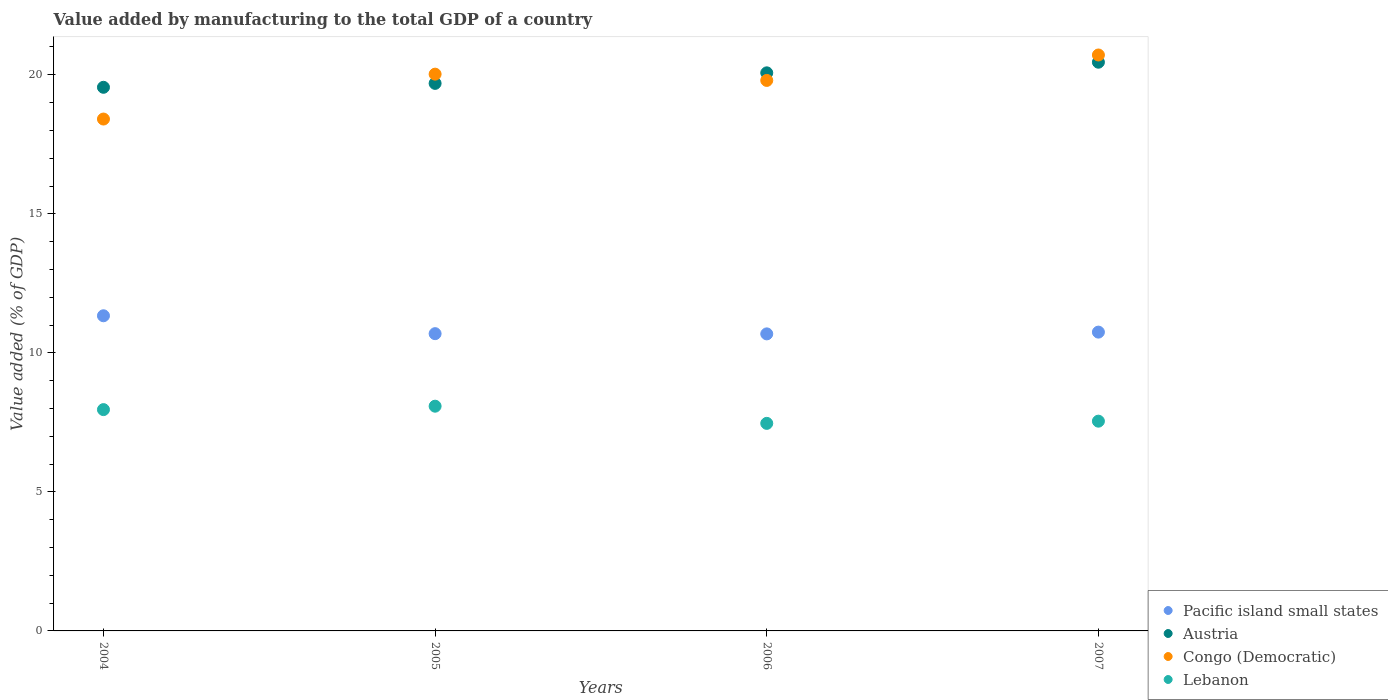How many different coloured dotlines are there?
Your answer should be very brief. 4. What is the value added by manufacturing to the total GDP in Austria in 2007?
Your response must be concise. 20.45. Across all years, what is the maximum value added by manufacturing to the total GDP in Pacific island small states?
Make the answer very short. 11.33. Across all years, what is the minimum value added by manufacturing to the total GDP in Pacific island small states?
Offer a terse response. 10.68. In which year was the value added by manufacturing to the total GDP in Pacific island small states minimum?
Make the answer very short. 2006. What is the total value added by manufacturing to the total GDP in Congo (Democratic) in the graph?
Ensure brevity in your answer.  78.94. What is the difference between the value added by manufacturing to the total GDP in Austria in 2006 and that in 2007?
Offer a very short reply. -0.38. What is the difference between the value added by manufacturing to the total GDP in Austria in 2004 and the value added by manufacturing to the total GDP in Pacific island small states in 2005?
Your answer should be compact. 8.86. What is the average value added by manufacturing to the total GDP in Lebanon per year?
Provide a short and direct response. 7.76. In the year 2006, what is the difference between the value added by manufacturing to the total GDP in Austria and value added by manufacturing to the total GDP in Pacific island small states?
Your response must be concise. 9.39. In how many years, is the value added by manufacturing to the total GDP in Lebanon greater than 1 %?
Your response must be concise. 4. What is the ratio of the value added by manufacturing to the total GDP in Pacific island small states in 2004 to that in 2005?
Keep it short and to the point. 1.06. What is the difference between the highest and the second highest value added by manufacturing to the total GDP in Lebanon?
Ensure brevity in your answer.  0.12. What is the difference between the highest and the lowest value added by manufacturing to the total GDP in Pacific island small states?
Your answer should be very brief. 0.65. Is the sum of the value added by manufacturing to the total GDP in Pacific island small states in 2004 and 2006 greater than the maximum value added by manufacturing to the total GDP in Austria across all years?
Your answer should be compact. Yes. Is it the case that in every year, the sum of the value added by manufacturing to the total GDP in Congo (Democratic) and value added by manufacturing to the total GDP in Pacific island small states  is greater than the sum of value added by manufacturing to the total GDP in Austria and value added by manufacturing to the total GDP in Lebanon?
Make the answer very short. Yes. Is it the case that in every year, the sum of the value added by manufacturing to the total GDP in Pacific island small states and value added by manufacturing to the total GDP in Austria  is greater than the value added by manufacturing to the total GDP in Congo (Democratic)?
Offer a very short reply. Yes. Is the value added by manufacturing to the total GDP in Austria strictly greater than the value added by manufacturing to the total GDP in Congo (Democratic) over the years?
Offer a terse response. No. Is the value added by manufacturing to the total GDP in Austria strictly less than the value added by manufacturing to the total GDP in Lebanon over the years?
Offer a terse response. No. Are the values on the major ticks of Y-axis written in scientific E-notation?
Offer a very short reply. No. Does the graph contain grids?
Offer a terse response. No. What is the title of the graph?
Give a very brief answer. Value added by manufacturing to the total GDP of a country. What is the label or title of the Y-axis?
Provide a succinct answer. Value added (% of GDP). What is the Value added (% of GDP) in Pacific island small states in 2004?
Offer a very short reply. 11.33. What is the Value added (% of GDP) in Austria in 2004?
Give a very brief answer. 19.55. What is the Value added (% of GDP) of Congo (Democratic) in 2004?
Offer a very short reply. 18.41. What is the Value added (% of GDP) of Lebanon in 2004?
Provide a short and direct response. 7.96. What is the Value added (% of GDP) in Pacific island small states in 2005?
Give a very brief answer. 10.69. What is the Value added (% of GDP) of Austria in 2005?
Your answer should be very brief. 19.69. What is the Value added (% of GDP) of Congo (Democratic) in 2005?
Give a very brief answer. 20.02. What is the Value added (% of GDP) of Lebanon in 2005?
Offer a terse response. 8.08. What is the Value added (% of GDP) in Pacific island small states in 2006?
Your response must be concise. 10.68. What is the Value added (% of GDP) in Austria in 2006?
Keep it short and to the point. 20.07. What is the Value added (% of GDP) of Congo (Democratic) in 2006?
Give a very brief answer. 19.8. What is the Value added (% of GDP) of Lebanon in 2006?
Provide a succinct answer. 7.46. What is the Value added (% of GDP) of Pacific island small states in 2007?
Your answer should be compact. 10.75. What is the Value added (% of GDP) in Austria in 2007?
Give a very brief answer. 20.45. What is the Value added (% of GDP) of Congo (Democratic) in 2007?
Your response must be concise. 20.71. What is the Value added (% of GDP) of Lebanon in 2007?
Your answer should be very brief. 7.54. Across all years, what is the maximum Value added (% of GDP) of Pacific island small states?
Make the answer very short. 11.33. Across all years, what is the maximum Value added (% of GDP) in Austria?
Your response must be concise. 20.45. Across all years, what is the maximum Value added (% of GDP) of Congo (Democratic)?
Provide a short and direct response. 20.71. Across all years, what is the maximum Value added (% of GDP) in Lebanon?
Offer a very short reply. 8.08. Across all years, what is the minimum Value added (% of GDP) in Pacific island small states?
Your answer should be compact. 10.68. Across all years, what is the minimum Value added (% of GDP) of Austria?
Offer a terse response. 19.55. Across all years, what is the minimum Value added (% of GDP) in Congo (Democratic)?
Your answer should be compact. 18.41. Across all years, what is the minimum Value added (% of GDP) in Lebanon?
Provide a succinct answer. 7.46. What is the total Value added (% of GDP) of Pacific island small states in the graph?
Provide a short and direct response. 43.45. What is the total Value added (% of GDP) in Austria in the graph?
Your response must be concise. 79.76. What is the total Value added (% of GDP) in Congo (Democratic) in the graph?
Your answer should be very brief. 78.94. What is the total Value added (% of GDP) in Lebanon in the graph?
Give a very brief answer. 31.05. What is the difference between the Value added (% of GDP) in Pacific island small states in 2004 and that in 2005?
Ensure brevity in your answer.  0.64. What is the difference between the Value added (% of GDP) of Austria in 2004 and that in 2005?
Offer a terse response. -0.14. What is the difference between the Value added (% of GDP) of Congo (Democratic) in 2004 and that in 2005?
Offer a terse response. -1.61. What is the difference between the Value added (% of GDP) of Lebanon in 2004 and that in 2005?
Provide a succinct answer. -0.12. What is the difference between the Value added (% of GDP) in Pacific island small states in 2004 and that in 2006?
Your answer should be compact. 0.65. What is the difference between the Value added (% of GDP) of Austria in 2004 and that in 2006?
Provide a succinct answer. -0.52. What is the difference between the Value added (% of GDP) in Congo (Democratic) in 2004 and that in 2006?
Your answer should be compact. -1.39. What is the difference between the Value added (% of GDP) in Lebanon in 2004 and that in 2006?
Provide a succinct answer. 0.49. What is the difference between the Value added (% of GDP) in Pacific island small states in 2004 and that in 2007?
Ensure brevity in your answer.  0.59. What is the difference between the Value added (% of GDP) in Austria in 2004 and that in 2007?
Provide a short and direct response. -0.9. What is the difference between the Value added (% of GDP) in Congo (Democratic) in 2004 and that in 2007?
Offer a very short reply. -2.3. What is the difference between the Value added (% of GDP) in Lebanon in 2004 and that in 2007?
Make the answer very short. 0.42. What is the difference between the Value added (% of GDP) of Pacific island small states in 2005 and that in 2006?
Provide a short and direct response. 0.01. What is the difference between the Value added (% of GDP) in Austria in 2005 and that in 2006?
Provide a short and direct response. -0.38. What is the difference between the Value added (% of GDP) of Congo (Democratic) in 2005 and that in 2006?
Provide a short and direct response. 0.23. What is the difference between the Value added (% of GDP) of Lebanon in 2005 and that in 2006?
Offer a terse response. 0.62. What is the difference between the Value added (% of GDP) in Pacific island small states in 2005 and that in 2007?
Offer a terse response. -0.06. What is the difference between the Value added (% of GDP) of Austria in 2005 and that in 2007?
Your response must be concise. -0.76. What is the difference between the Value added (% of GDP) in Congo (Democratic) in 2005 and that in 2007?
Ensure brevity in your answer.  -0.69. What is the difference between the Value added (% of GDP) in Lebanon in 2005 and that in 2007?
Offer a very short reply. 0.54. What is the difference between the Value added (% of GDP) in Pacific island small states in 2006 and that in 2007?
Provide a succinct answer. -0.06. What is the difference between the Value added (% of GDP) of Austria in 2006 and that in 2007?
Provide a succinct answer. -0.38. What is the difference between the Value added (% of GDP) of Congo (Democratic) in 2006 and that in 2007?
Your answer should be compact. -0.91. What is the difference between the Value added (% of GDP) in Lebanon in 2006 and that in 2007?
Offer a very short reply. -0.08. What is the difference between the Value added (% of GDP) in Pacific island small states in 2004 and the Value added (% of GDP) in Austria in 2005?
Provide a short and direct response. -8.36. What is the difference between the Value added (% of GDP) of Pacific island small states in 2004 and the Value added (% of GDP) of Congo (Democratic) in 2005?
Your answer should be very brief. -8.69. What is the difference between the Value added (% of GDP) in Pacific island small states in 2004 and the Value added (% of GDP) in Lebanon in 2005?
Make the answer very short. 3.25. What is the difference between the Value added (% of GDP) in Austria in 2004 and the Value added (% of GDP) in Congo (Democratic) in 2005?
Your answer should be compact. -0.47. What is the difference between the Value added (% of GDP) in Austria in 2004 and the Value added (% of GDP) in Lebanon in 2005?
Offer a terse response. 11.47. What is the difference between the Value added (% of GDP) of Congo (Democratic) in 2004 and the Value added (% of GDP) of Lebanon in 2005?
Offer a terse response. 10.33. What is the difference between the Value added (% of GDP) in Pacific island small states in 2004 and the Value added (% of GDP) in Austria in 2006?
Your answer should be very brief. -8.74. What is the difference between the Value added (% of GDP) in Pacific island small states in 2004 and the Value added (% of GDP) in Congo (Democratic) in 2006?
Give a very brief answer. -8.46. What is the difference between the Value added (% of GDP) of Pacific island small states in 2004 and the Value added (% of GDP) of Lebanon in 2006?
Keep it short and to the point. 3.87. What is the difference between the Value added (% of GDP) of Austria in 2004 and the Value added (% of GDP) of Congo (Democratic) in 2006?
Your answer should be compact. -0.25. What is the difference between the Value added (% of GDP) of Austria in 2004 and the Value added (% of GDP) of Lebanon in 2006?
Provide a succinct answer. 12.09. What is the difference between the Value added (% of GDP) of Congo (Democratic) in 2004 and the Value added (% of GDP) of Lebanon in 2006?
Your answer should be very brief. 10.94. What is the difference between the Value added (% of GDP) of Pacific island small states in 2004 and the Value added (% of GDP) of Austria in 2007?
Keep it short and to the point. -9.12. What is the difference between the Value added (% of GDP) of Pacific island small states in 2004 and the Value added (% of GDP) of Congo (Democratic) in 2007?
Offer a terse response. -9.38. What is the difference between the Value added (% of GDP) in Pacific island small states in 2004 and the Value added (% of GDP) in Lebanon in 2007?
Your response must be concise. 3.79. What is the difference between the Value added (% of GDP) of Austria in 2004 and the Value added (% of GDP) of Congo (Democratic) in 2007?
Ensure brevity in your answer.  -1.16. What is the difference between the Value added (% of GDP) of Austria in 2004 and the Value added (% of GDP) of Lebanon in 2007?
Your answer should be compact. 12.01. What is the difference between the Value added (% of GDP) of Congo (Democratic) in 2004 and the Value added (% of GDP) of Lebanon in 2007?
Your answer should be compact. 10.86. What is the difference between the Value added (% of GDP) in Pacific island small states in 2005 and the Value added (% of GDP) in Austria in 2006?
Your response must be concise. -9.38. What is the difference between the Value added (% of GDP) of Pacific island small states in 2005 and the Value added (% of GDP) of Congo (Democratic) in 2006?
Keep it short and to the point. -9.11. What is the difference between the Value added (% of GDP) of Pacific island small states in 2005 and the Value added (% of GDP) of Lebanon in 2006?
Ensure brevity in your answer.  3.23. What is the difference between the Value added (% of GDP) of Austria in 2005 and the Value added (% of GDP) of Congo (Democratic) in 2006?
Keep it short and to the point. -0.11. What is the difference between the Value added (% of GDP) in Austria in 2005 and the Value added (% of GDP) in Lebanon in 2006?
Your answer should be very brief. 12.23. What is the difference between the Value added (% of GDP) of Congo (Democratic) in 2005 and the Value added (% of GDP) of Lebanon in 2006?
Provide a short and direct response. 12.56. What is the difference between the Value added (% of GDP) in Pacific island small states in 2005 and the Value added (% of GDP) in Austria in 2007?
Keep it short and to the point. -9.76. What is the difference between the Value added (% of GDP) in Pacific island small states in 2005 and the Value added (% of GDP) in Congo (Democratic) in 2007?
Ensure brevity in your answer.  -10.02. What is the difference between the Value added (% of GDP) of Pacific island small states in 2005 and the Value added (% of GDP) of Lebanon in 2007?
Your answer should be very brief. 3.15. What is the difference between the Value added (% of GDP) of Austria in 2005 and the Value added (% of GDP) of Congo (Democratic) in 2007?
Offer a terse response. -1.02. What is the difference between the Value added (% of GDP) in Austria in 2005 and the Value added (% of GDP) in Lebanon in 2007?
Your answer should be compact. 12.15. What is the difference between the Value added (% of GDP) of Congo (Democratic) in 2005 and the Value added (% of GDP) of Lebanon in 2007?
Give a very brief answer. 12.48. What is the difference between the Value added (% of GDP) of Pacific island small states in 2006 and the Value added (% of GDP) of Austria in 2007?
Offer a very short reply. -9.77. What is the difference between the Value added (% of GDP) in Pacific island small states in 2006 and the Value added (% of GDP) in Congo (Democratic) in 2007?
Your answer should be compact. -10.03. What is the difference between the Value added (% of GDP) of Pacific island small states in 2006 and the Value added (% of GDP) of Lebanon in 2007?
Your answer should be very brief. 3.14. What is the difference between the Value added (% of GDP) in Austria in 2006 and the Value added (% of GDP) in Congo (Democratic) in 2007?
Your answer should be compact. -0.64. What is the difference between the Value added (% of GDP) in Austria in 2006 and the Value added (% of GDP) in Lebanon in 2007?
Provide a succinct answer. 12.53. What is the difference between the Value added (% of GDP) of Congo (Democratic) in 2006 and the Value added (% of GDP) of Lebanon in 2007?
Make the answer very short. 12.25. What is the average Value added (% of GDP) in Pacific island small states per year?
Offer a terse response. 10.86. What is the average Value added (% of GDP) in Austria per year?
Provide a short and direct response. 19.94. What is the average Value added (% of GDP) in Congo (Democratic) per year?
Keep it short and to the point. 19.73. What is the average Value added (% of GDP) in Lebanon per year?
Give a very brief answer. 7.76. In the year 2004, what is the difference between the Value added (% of GDP) of Pacific island small states and Value added (% of GDP) of Austria?
Your answer should be compact. -8.22. In the year 2004, what is the difference between the Value added (% of GDP) in Pacific island small states and Value added (% of GDP) in Congo (Democratic)?
Your answer should be very brief. -7.07. In the year 2004, what is the difference between the Value added (% of GDP) of Pacific island small states and Value added (% of GDP) of Lebanon?
Provide a succinct answer. 3.37. In the year 2004, what is the difference between the Value added (% of GDP) of Austria and Value added (% of GDP) of Congo (Democratic)?
Offer a very short reply. 1.14. In the year 2004, what is the difference between the Value added (% of GDP) of Austria and Value added (% of GDP) of Lebanon?
Your answer should be compact. 11.59. In the year 2004, what is the difference between the Value added (% of GDP) in Congo (Democratic) and Value added (% of GDP) in Lebanon?
Your response must be concise. 10.45. In the year 2005, what is the difference between the Value added (% of GDP) in Pacific island small states and Value added (% of GDP) in Austria?
Your response must be concise. -9. In the year 2005, what is the difference between the Value added (% of GDP) in Pacific island small states and Value added (% of GDP) in Congo (Democratic)?
Give a very brief answer. -9.33. In the year 2005, what is the difference between the Value added (% of GDP) in Pacific island small states and Value added (% of GDP) in Lebanon?
Give a very brief answer. 2.61. In the year 2005, what is the difference between the Value added (% of GDP) of Austria and Value added (% of GDP) of Congo (Democratic)?
Provide a short and direct response. -0.33. In the year 2005, what is the difference between the Value added (% of GDP) of Austria and Value added (% of GDP) of Lebanon?
Ensure brevity in your answer.  11.61. In the year 2005, what is the difference between the Value added (% of GDP) of Congo (Democratic) and Value added (% of GDP) of Lebanon?
Make the answer very short. 11.94. In the year 2006, what is the difference between the Value added (% of GDP) of Pacific island small states and Value added (% of GDP) of Austria?
Provide a succinct answer. -9.39. In the year 2006, what is the difference between the Value added (% of GDP) of Pacific island small states and Value added (% of GDP) of Congo (Democratic)?
Make the answer very short. -9.12. In the year 2006, what is the difference between the Value added (% of GDP) of Pacific island small states and Value added (% of GDP) of Lebanon?
Ensure brevity in your answer.  3.22. In the year 2006, what is the difference between the Value added (% of GDP) in Austria and Value added (% of GDP) in Congo (Democratic)?
Your answer should be very brief. 0.27. In the year 2006, what is the difference between the Value added (% of GDP) in Austria and Value added (% of GDP) in Lebanon?
Ensure brevity in your answer.  12.61. In the year 2006, what is the difference between the Value added (% of GDP) of Congo (Democratic) and Value added (% of GDP) of Lebanon?
Your response must be concise. 12.33. In the year 2007, what is the difference between the Value added (% of GDP) in Pacific island small states and Value added (% of GDP) in Austria?
Provide a succinct answer. -9.71. In the year 2007, what is the difference between the Value added (% of GDP) of Pacific island small states and Value added (% of GDP) of Congo (Democratic)?
Offer a terse response. -9.97. In the year 2007, what is the difference between the Value added (% of GDP) in Pacific island small states and Value added (% of GDP) in Lebanon?
Provide a short and direct response. 3.2. In the year 2007, what is the difference between the Value added (% of GDP) in Austria and Value added (% of GDP) in Congo (Democratic)?
Provide a succinct answer. -0.26. In the year 2007, what is the difference between the Value added (% of GDP) of Austria and Value added (% of GDP) of Lebanon?
Offer a terse response. 12.91. In the year 2007, what is the difference between the Value added (% of GDP) in Congo (Democratic) and Value added (% of GDP) in Lebanon?
Give a very brief answer. 13.17. What is the ratio of the Value added (% of GDP) in Pacific island small states in 2004 to that in 2005?
Ensure brevity in your answer.  1.06. What is the ratio of the Value added (% of GDP) of Austria in 2004 to that in 2005?
Offer a terse response. 0.99. What is the ratio of the Value added (% of GDP) of Congo (Democratic) in 2004 to that in 2005?
Offer a very short reply. 0.92. What is the ratio of the Value added (% of GDP) in Lebanon in 2004 to that in 2005?
Provide a short and direct response. 0.98. What is the ratio of the Value added (% of GDP) of Pacific island small states in 2004 to that in 2006?
Make the answer very short. 1.06. What is the ratio of the Value added (% of GDP) in Austria in 2004 to that in 2006?
Offer a very short reply. 0.97. What is the ratio of the Value added (% of GDP) in Congo (Democratic) in 2004 to that in 2006?
Provide a short and direct response. 0.93. What is the ratio of the Value added (% of GDP) of Lebanon in 2004 to that in 2006?
Ensure brevity in your answer.  1.07. What is the ratio of the Value added (% of GDP) in Pacific island small states in 2004 to that in 2007?
Provide a short and direct response. 1.05. What is the ratio of the Value added (% of GDP) in Austria in 2004 to that in 2007?
Ensure brevity in your answer.  0.96. What is the ratio of the Value added (% of GDP) of Congo (Democratic) in 2004 to that in 2007?
Ensure brevity in your answer.  0.89. What is the ratio of the Value added (% of GDP) in Lebanon in 2004 to that in 2007?
Give a very brief answer. 1.06. What is the ratio of the Value added (% of GDP) in Austria in 2005 to that in 2006?
Offer a terse response. 0.98. What is the ratio of the Value added (% of GDP) of Congo (Democratic) in 2005 to that in 2006?
Make the answer very short. 1.01. What is the ratio of the Value added (% of GDP) of Lebanon in 2005 to that in 2006?
Offer a terse response. 1.08. What is the ratio of the Value added (% of GDP) of Pacific island small states in 2005 to that in 2007?
Keep it short and to the point. 0.99. What is the ratio of the Value added (% of GDP) in Austria in 2005 to that in 2007?
Ensure brevity in your answer.  0.96. What is the ratio of the Value added (% of GDP) of Congo (Democratic) in 2005 to that in 2007?
Make the answer very short. 0.97. What is the ratio of the Value added (% of GDP) in Lebanon in 2005 to that in 2007?
Your answer should be compact. 1.07. What is the ratio of the Value added (% of GDP) in Pacific island small states in 2006 to that in 2007?
Your answer should be compact. 0.99. What is the ratio of the Value added (% of GDP) of Austria in 2006 to that in 2007?
Ensure brevity in your answer.  0.98. What is the ratio of the Value added (% of GDP) in Congo (Democratic) in 2006 to that in 2007?
Keep it short and to the point. 0.96. What is the difference between the highest and the second highest Value added (% of GDP) in Pacific island small states?
Provide a short and direct response. 0.59. What is the difference between the highest and the second highest Value added (% of GDP) in Austria?
Provide a short and direct response. 0.38. What is the difference between the highest and the second highest Value added (% of GDP) of Congo (Democratic)?
Offer a terse response. 0.69. What is the difference between the highest and the second highest Value added (% of GDP) in Lebanon?
Offer a very short reply. 0.12. What is the difference between the highest and the lowest Value added (% of GDP) of Pacific island small states?
Keep it short and to the point. 0.65. What is the difference between the highest and the lowest Value added (% of GDP) of Austria?
Make the answer very short. 0.9. What is the difference between the highest and the lowest Value added (% of GDP) of Congo (Democratic)?
Ensure brevity in your answer.  2.3. What is the difference between the highest and the lowest Value added (% of GDP) of Lebanon?
Your answer should be very brief. 0.62. 